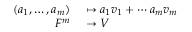<formula> <loc_0><loc_0><loc_500><loc_500>\begin{array} { r l } { ( a _ { 1 } , \dots , a _ { m } ) } & \mapsto a _ { 1 } v _ { 1 } + \cdots a _ { m } v _ { m } } \\ { F ^ { m } } & \to V } \end{array}</formula> 